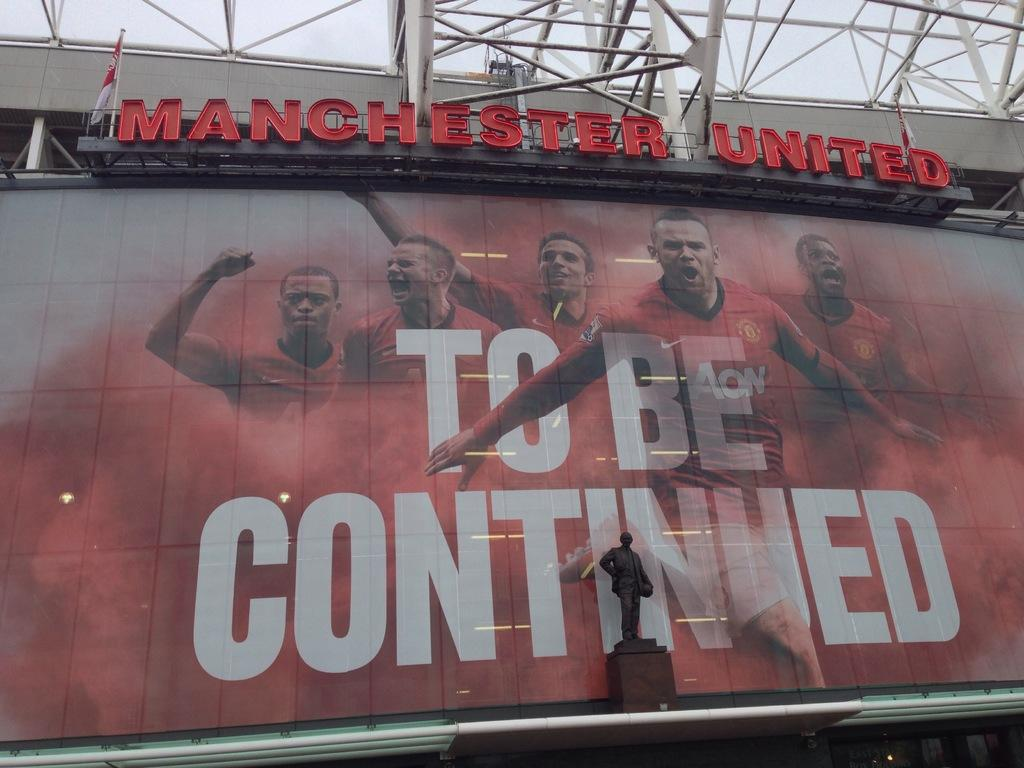<image>
Offer a succinct explanation of the picture presented. A billboard at Manchester united that says to be continued 